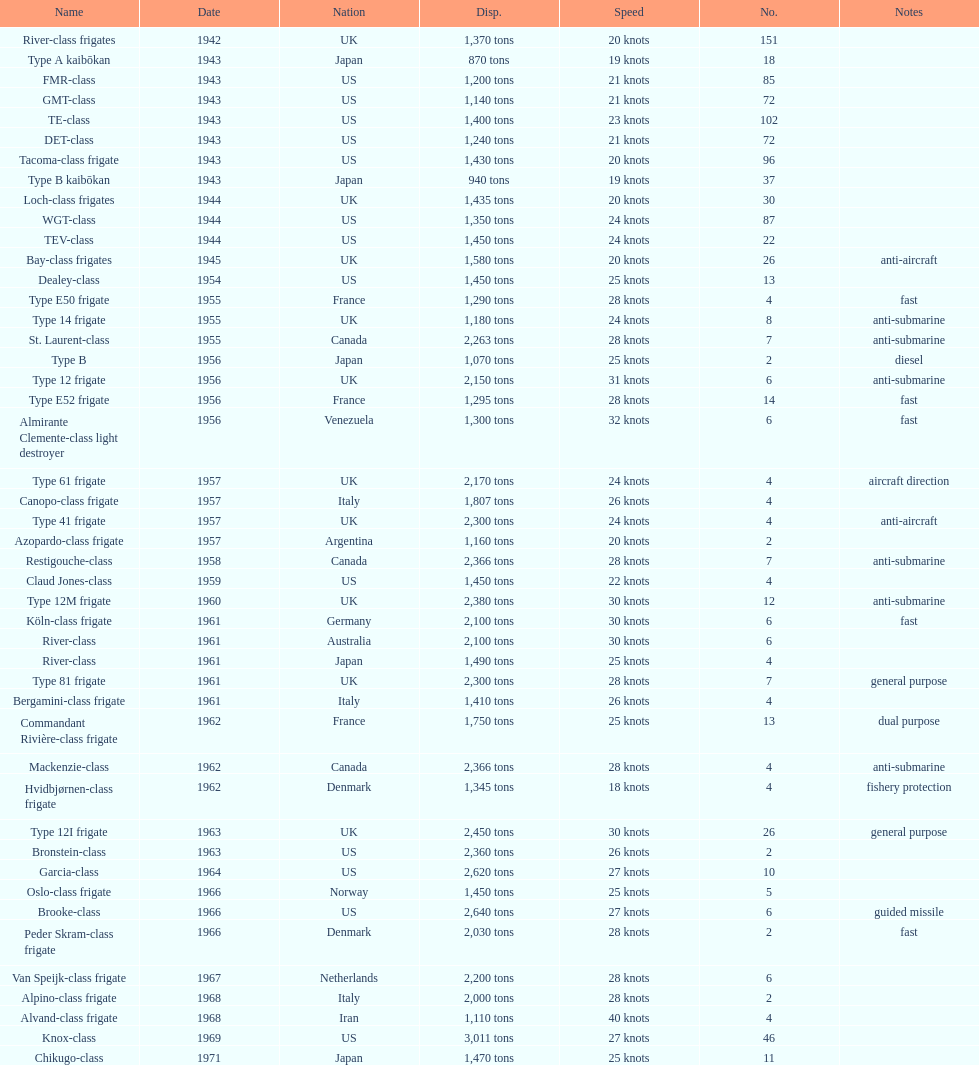How many tons of displacement does type b have? 940 tons. Parse the full table. {'header': ['Name', 'Date', 'Nation', 'Disp.', 'Speed', 'No.', 'Notes'], 'rows': [['River-class frigates', '1942', 'UK', '1,370 tons', '20 knots', '151', ''], ['Type A kaibōkan', '1943', 'Japan', '870 tons', '19 knots', '18', ''], ['FMR-class', '1943', 'US', '1,200 tons', '21 knots', '85', ''], ['GMT-class', '1943', 'US', '1,140 tons', '21 knots', '72', ''], ['TE-class', '1943', 'US', '1,400 tons', '23 knots', '102', ''], ['DET-class', '1943', 'US', '1,240 tons', '21 knots', '72', ''], ['Tacoma-class frigate', '1943', 'US', '1,430 tons', '20 knots', '96', ''], ['Type B kaibōkan', '1943', 'Japan', '940 tons', '19 knots', '37', ''], ['Loch-class frigates', '1944', 'UK', '1,435 tons', '20 knots', '30', ''], ['WGT-class', '1944', 'US', '1,350 tons', '24 knots', '87', ''], ['TEV-class', '1944', 'US', '1,450 tons', '24 knots', '22', ''], ['Bay-class frigates', '1945', 'UK', '1,580 tons', '20 knots', '26', 'anti-aircraft'], ['Dealey-class', '1954', 'US', '1,450 tons', '25 knots', '13', ''], ['Type E50 frigate', '1955', 'France', '1,290 tons', '28 knots', '4', 'fast'], ['Type 14 frigate', '1955', 'UK', '1,180 tons', '24 knots', '8', 'anti-submarine'], ['St. Laurent-class', '1955', 'Canada', '2,263 tons', '28 knots', '7', 'anti-submarine'], ['Type B', '1956', 'Japan', '1,070 tons', '25 knots', '2', 'diesel'], ['Type 12 frigate', '1956', 'UK', '2,150 tons', '31 knots', '6', 'anti-submarine'], ['Type E52 frigate', '1956', 'France', '1,295 tons', '28 knots', '14', 'fast'], ['Almirante Clemente-class light destroyer', '1956', 'Venezuela', '1,300 tons', '32 knots', '6', 'fast'], ['Type 61 frigate', '1957', 'UK', '2,170 tons', '24 knots', '4', 'aircraft direction'], ['Canopo-class frigate', '1957', 'Italy', '1,807 tons', '26 knots', '4', ''], ['Type 41 frigate', '1957', 'UK', '2,300 tons', '24 knots', '4', 'anti-aircraft'], ['Azopardo-class frigate', '1957', 'Argentina', '1,160 tons', '20 knots', '2', ''], ['Restigouche-class', '1958', 'Canada', '2,366 tons', '28 knots', '7', 'anti-submarine'], ['Claud Jones-class', '1959', 'US', '1,450 tons', '22 knots', '4', ''], ['Type 12M frigate', '1960', 'UK', '2,380 tons', '30 knots', '12', 'anti-submarine'], ['Köln-class frigate', '1961', 'Germany', '2,100 tons', '30 knots', '6', 'fast'], ['River-class', '1961', 'Australia', '2,100 tons', '30 knots', '6', ''], ['River-class', '1961', 'Japan', '1,490 tons', '25 knots', '4', ''], ['Type 81 frigate', '1961', 'UK', '2,300 tons', '28 knots', '7', 'general purpose'], ['Bergamini-class frigate', '1961', 'Italy', '1,410 tons', '26 knots', '4', ''], ['Commandant Rivière-class frigate', '1962', 'France', '1,750 tons', '25 knots', '13', 'dual purpose'], ['Mackenzie-class', '1962', 'Canada', '2,366 tons', '28 knots', '4', 'anti-submarine'], ['Hvidbjørnen-class frigate', '1962', 'Denmark', '1,345 tons', '18 knots', '4', 'fishery protection'], ['Type 12I frigate', '1963', 'UK', '2,450 tons', '30 knots', '26', 'general purpose'], ['Bronstein-class', '1963', 'US', '2,360 tons', '26 knots', '2', ''], ['Garcia-class', '1964', 'US', '2,620 tons', '27 knots', '10', ''], ['Oslo-class frigate', '1966', 'Norway', '1,450 tons', '25 knots', '5', ''], ['Brooke-class', '1966', 'US', '2,640 tons', '27 knots', '6', 'guided missile'], ['Peder Skram-class frigate', '1966', 'Denmark', '2,030 tons', '28 knots', '2', 'fast'], ['Van Speijk-class frigate', '1967', 'Netherlands', '2,200 tons', '28 knots', '6', ''], ['Alpino-class frigate', '1968', 'Italy', '2,000 tons', '28 knots', '2', ''], ['Alvand-class frigate', '1968', 'Iran', '1,110 tons', '40 knots', '4', ''], ['Knox-class', '1969', 'US', '3,011 tons', '27 knots', '46', ''], ['Chikugo-class', '1971', 'Japan', '1,470 tons', '25 knots', '11', '']]} 